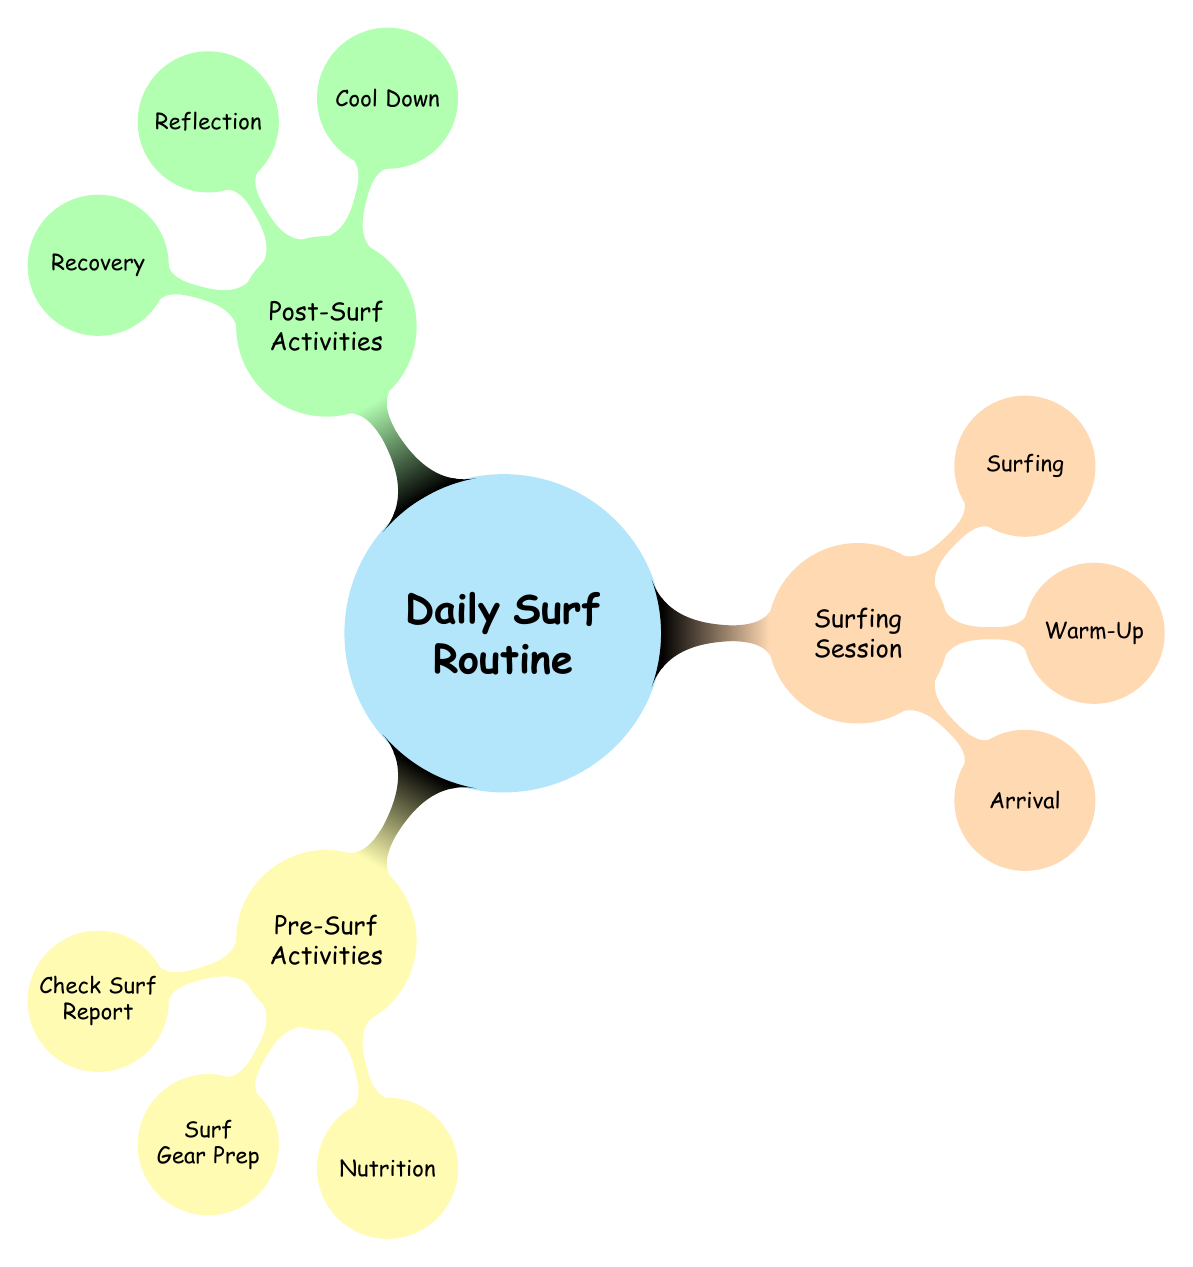What are the three main categories in the Daily Surf Routine? The Daily Surf Routine is divided into Pre-Surf Activities, Surfing Session, and Post-Surf Activities.
Answer: Pre-Surf Activities, Surfing Session, Post-Surf Activities How many activities are listed under Pre-Surf Activities? There are three activities: Check Surf Report, Surf Gear Prep, and Nutrition.
Answer: 3 Which activity is listed under Surfing Session that involves preparation before entering the water? The Warm-Up activity involves stretching, breathing exercises, and a short jog to prepare before surfing.
Answer: Warm-Up What are the two types of activities in Post-Surf Activities that focus on physical and mental recovery? The Cool Down focuses on physical recovery, while Reflection focuses on mental recovery through discussion and review.
Answer: Cool Down, Reflection Which activity involves social interaction during the Surfing Session? Meeting up with surfing buddies is an activity that involves social interaction before surfing.
Answer: Meet up with Surfing Buddies What is a common nutrition item mentioned in Pre-Surf Activities? A light snack such as a banana or yogurt is recommended in Nutrition under Pre-Surf Activities.
Answer: banana, yogurt What is one activity listed under Recovery in the Post-Surf Activities? Hydrate is one of the recovery activities suggested after surfing.
Answer: Hydrate How many nodes are there in the Surfing Session category? The Surfing Session category has three nodes: Arrival, Warm-Up, and Surfing.
Answer: 3 What is the purpose of the Reflective activity in Post-Surf Activities? The Reflective activity helps surfers discuss their experiences and review their techniques after surfing.
Answer: Discuss with Friends, Review Technique 